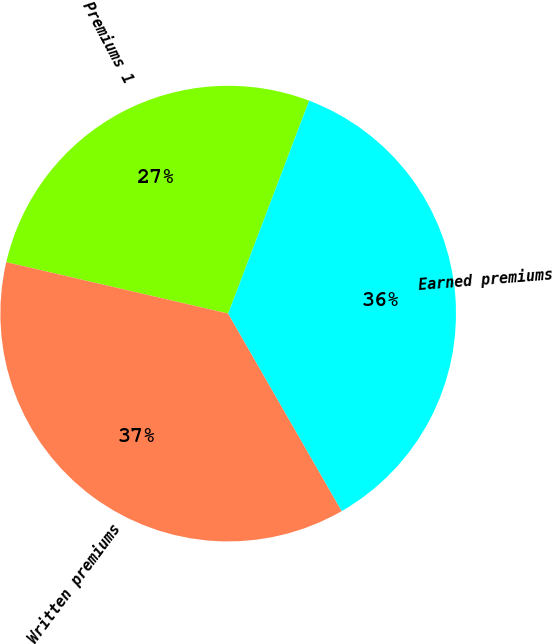<chart> <loc_0><loc_0><loc_500><loc_500><pie_chart><fcel>Premiums 1<fcel>Written premiums<fcel>Earned premiums<nl><fcel>27.16%<fcel>36.93%<fcel>35.91%<nl></chart> 